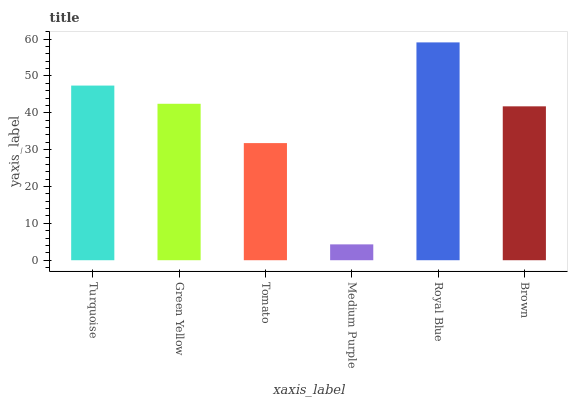Is Medium Purple the minimum?
Answer yes or no. Yes. Is Royal Blue the maximum?
Answer yes or no. Yes. Is Green Yellow the minimum?
Answer yes or no. No. Is Green Yellow the maximum?
Answer yes or no. No. Is Turquoise greater than Green Yellow?
Answer yes or no. Yes. Is Green Yellow less than Turquoise?
Answer yes or no. Yes. Is Green Yellow greater than Turquoise?
Answer yes or no. No. Is Turquoise less than Green Yellow?
Answer yes or no. No. Is Green Yellow the high median?
Answer yes or no. Yes. Is Brown the low median?
Answer yes or no. Yes. Is Tomato the high median?
Answer yes or no. No. Is Medium Purple the low median?
Answer yes or no. No. 